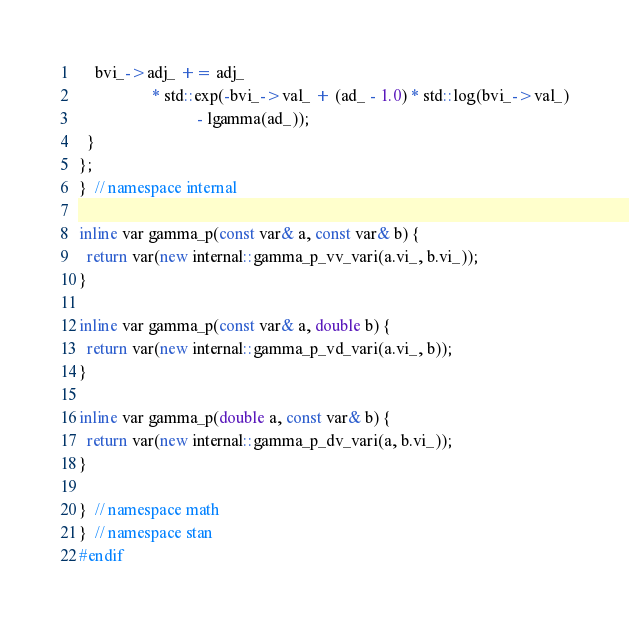Convert code to text. <code><loc_0><loc_0><loc_500><loc_500><_C++_>
    bvi_->adj_ += adj_
                  * std::exp(-bvi_->val_ + (ad_ - 1.0) * std::log(bvi_->val_)
                             - lgamma(ad_));
  }
};
}  // namespace internal

inline var gamma_p(const var& a, const var& b) {
  return var(new internal::gamma_p_vv_vari(a.vi_, b.vi_));
}

inline var gamma_p(const var& a, double b) {
  return var(new internal::gamma_p_vd_vari(a.vi_, b));
}

inline var gamma_p(double a, const var& b) {
  return var(new internal::gamma_p_dv_vari(a, b.vi_));
}

}  // namespace math
}  // namespace stan
#endif
</code> 